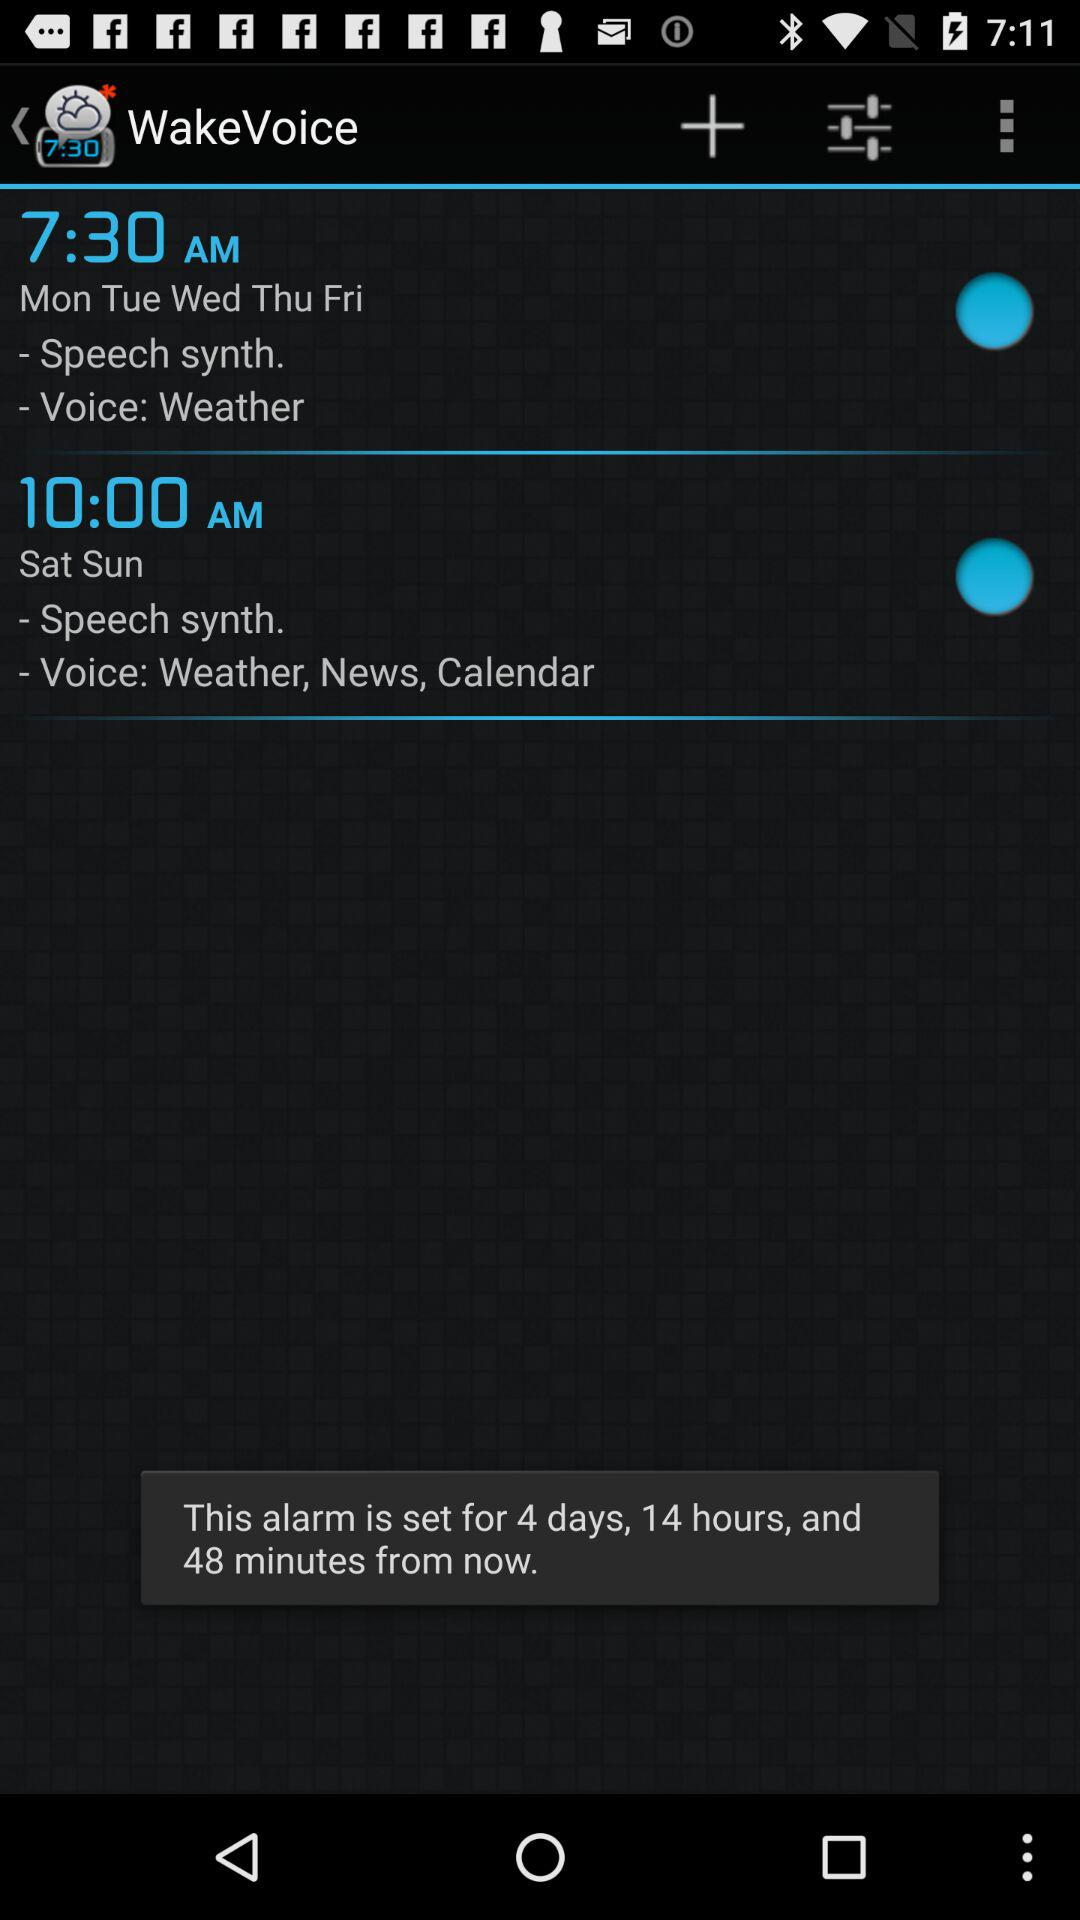What is the set alarm time for weekends? The set alarm time for weekends is 10 a.m. 